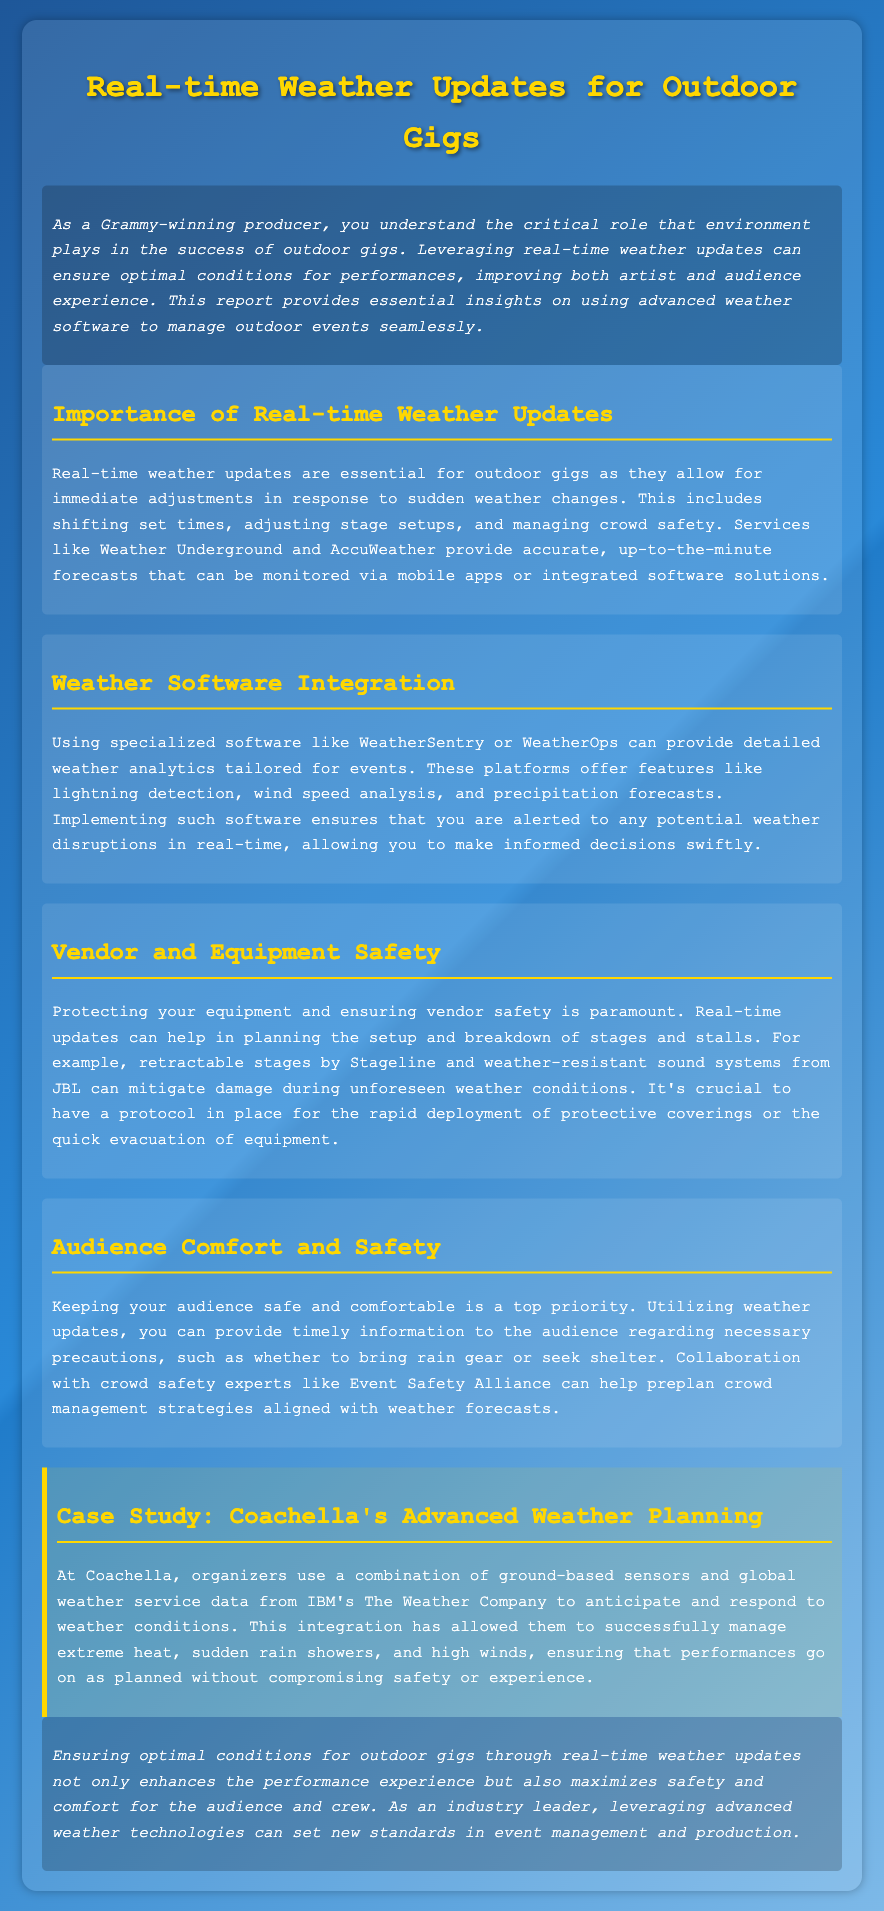What is the title of the document? The title of the document is found in the header section.
Answer: Real-time Weather Updates for Outdoor Gigs What is one software mentioned for weather integration? The document lists specific software used for weather analytics tailored for events.
Answer: WeatherSentry What type of conditions can real-time updates help manage? The document notes several areas affected by weather updates during outdoor gigs.
Answer: Sudden weather changes Which organization collaborates with event safety experts? The document identifies a specific organization that aids in preplanning crowd management strategies.
Answer: Event Safety Alliance What is the case study presented in the document? The document provides an example of an event that utilizes advanced weather planning.
Answer: Coachella's Advanced Weather Planning What is a feature offered by specialized weather software? The document mentions specific analytics features provided by advanced weather software.
Answer: Lightning detection How does advanced weather technology benefit performances? The document describes the overarching benefit of using advanced technologies in event management.
Answer: Enhances performance experience What color is used for headings in the document? The document specifies the color used for the h1 and h2 headings.
Answer: Gold 